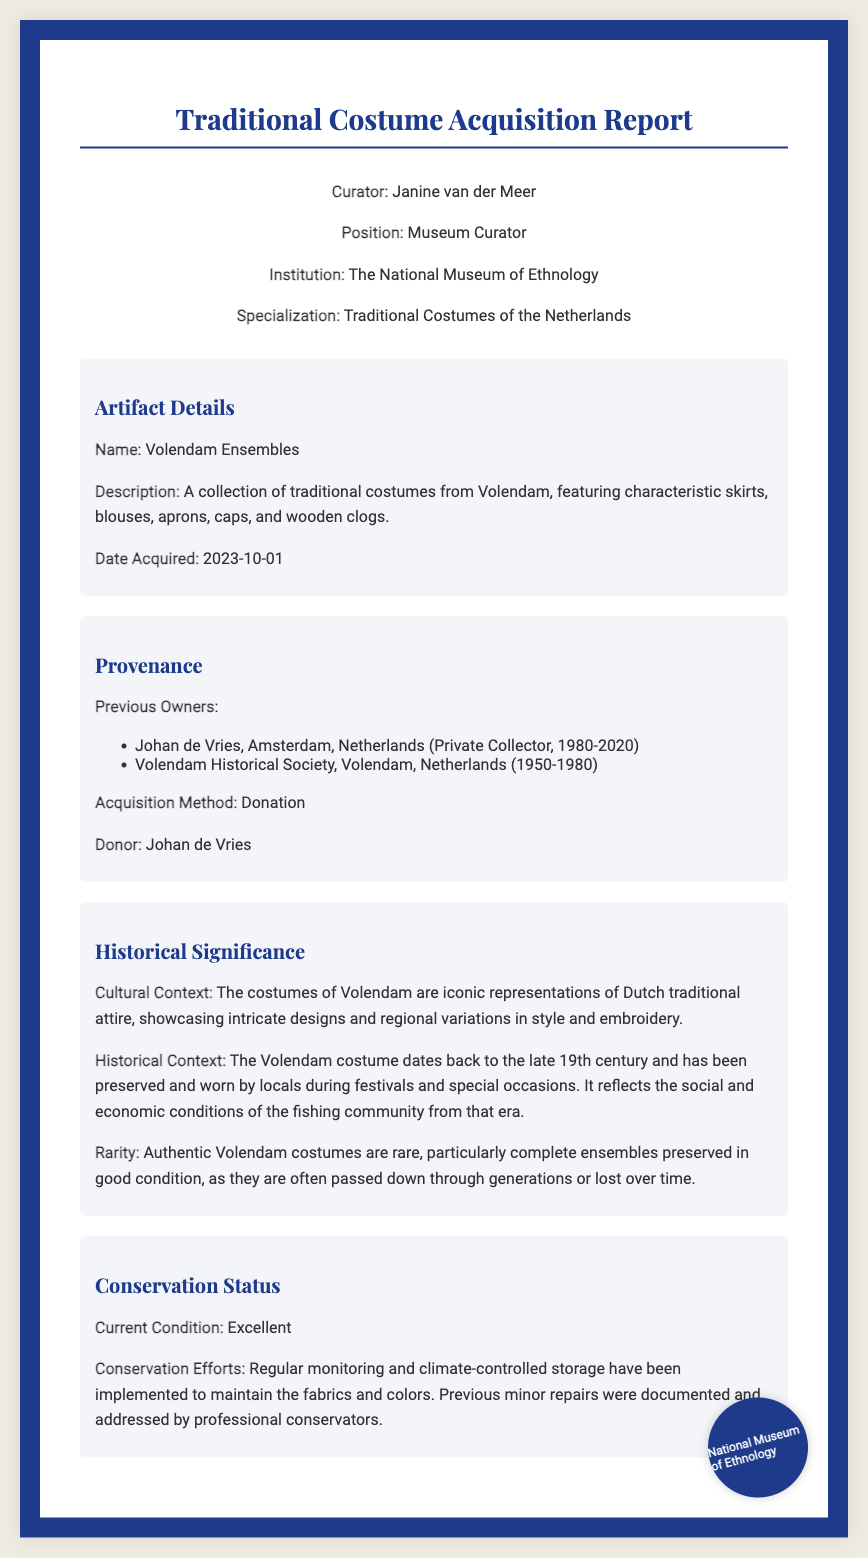What is the name of the artifact? The name of the artifact is mentioned in the artifact details section.
Answer: Volendam Ensembles Who was the previous owner before Johan de Vries? The previous owners are listed in the provenance section, with the first one before Johan de Vries stated.
Answer: Volendam Historical Society When was the costume acquired? The acquisition date is noted in the artifact details section of the diploma.
Answer: 2023-10-01 What acquisition method was used for the costume? The acquisition method is specified in the provenance section.
Answer: Donation What is the current condition of the costume? The current condition is noted in the conservation status section.
Answer: Excellent What cultural context is provided for the costumes? The cultural context is described in the historical significance section, detailing the representation of the costumes.
Answer: Iconic representations of Dutch traditional attire What year did Johan de Vries first own the costumes? The ownership period for Johan de Vries is outlined in the provenance section.
Answer: 1980 What organization donated the costume? The donor of the artifact is mentioned in the provenance section.
Answer: Johan de Vries What conservation efforts have been implemented? The conservation efforts are described in the conservation status section.
Answer: Regular monitoring and climate-controlled storage 